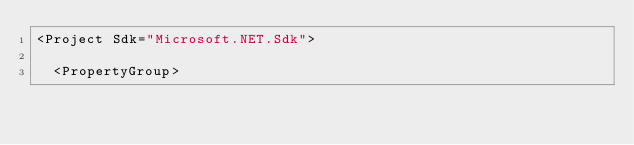Convert code to text. <code><loc_0><loc_0><loc_500><loc_500><_XML_><Project Sdk="Microsoft.NET.Sdk">

  <PropertyGroup></code> 